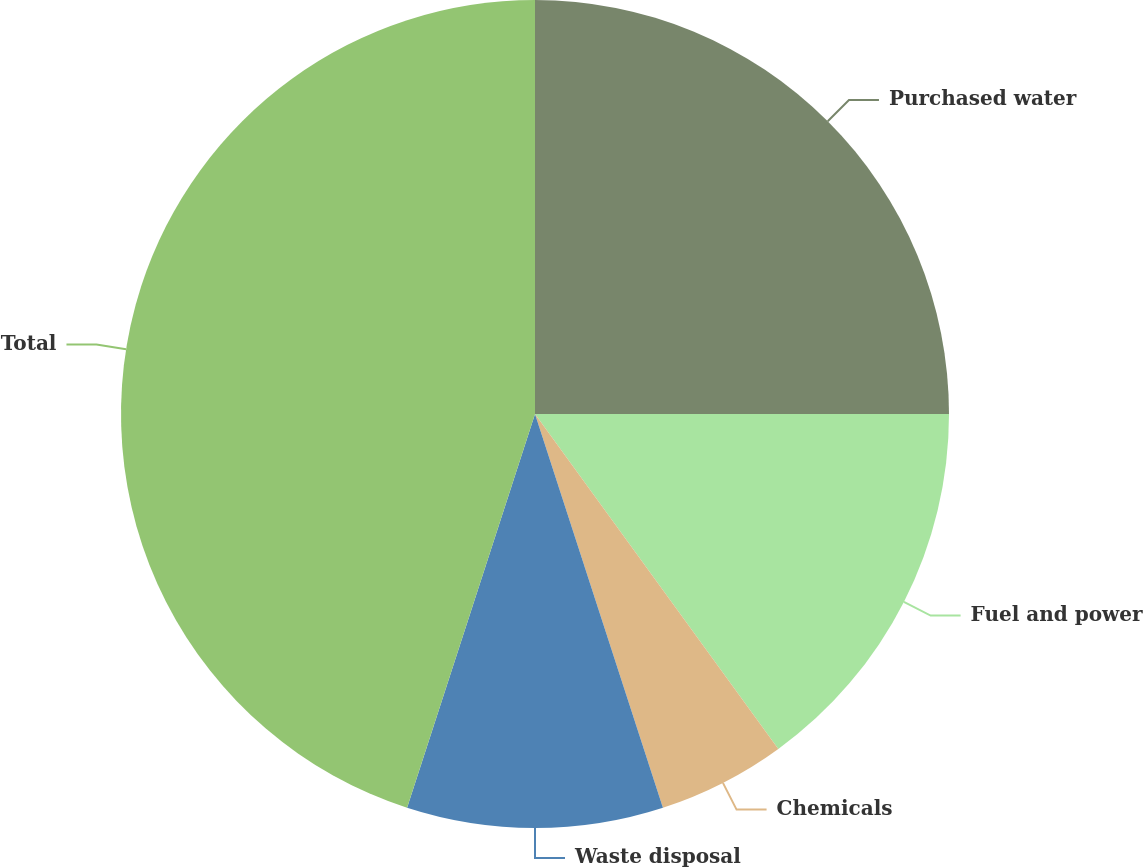<chart> <loc_0><loc_0><loc_500><loc_500><pie_chart><fcel>Purchased water<fcel>Fuel and power<fcel>Chemicals<fcel>Waste disposal<fcel>Total<nl><fcel>25.0%<fcel>15.0%<fcel>5.0%<fcel>10.0%<fcel>45.0%<nl></chart> 